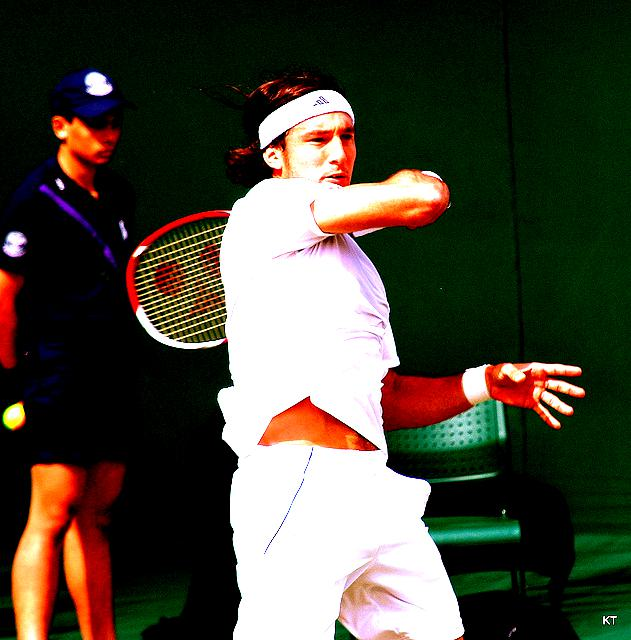Is the lighting sufficient? Based on the brightness and clarity visible in the image, the answer is 'B. Yes'. The subject and surrounding area are well-illuminated, allowing for easy visibility of details such as the tennis player's facial expression and the motion of the racket, indicating sufficient lighting. 